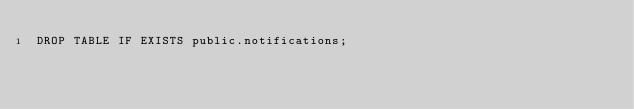<code> <loc_0><loc_0><loc_500><loc_500><_SQL_>DROP TABLE IF EXISTS public.notifications;</code> 